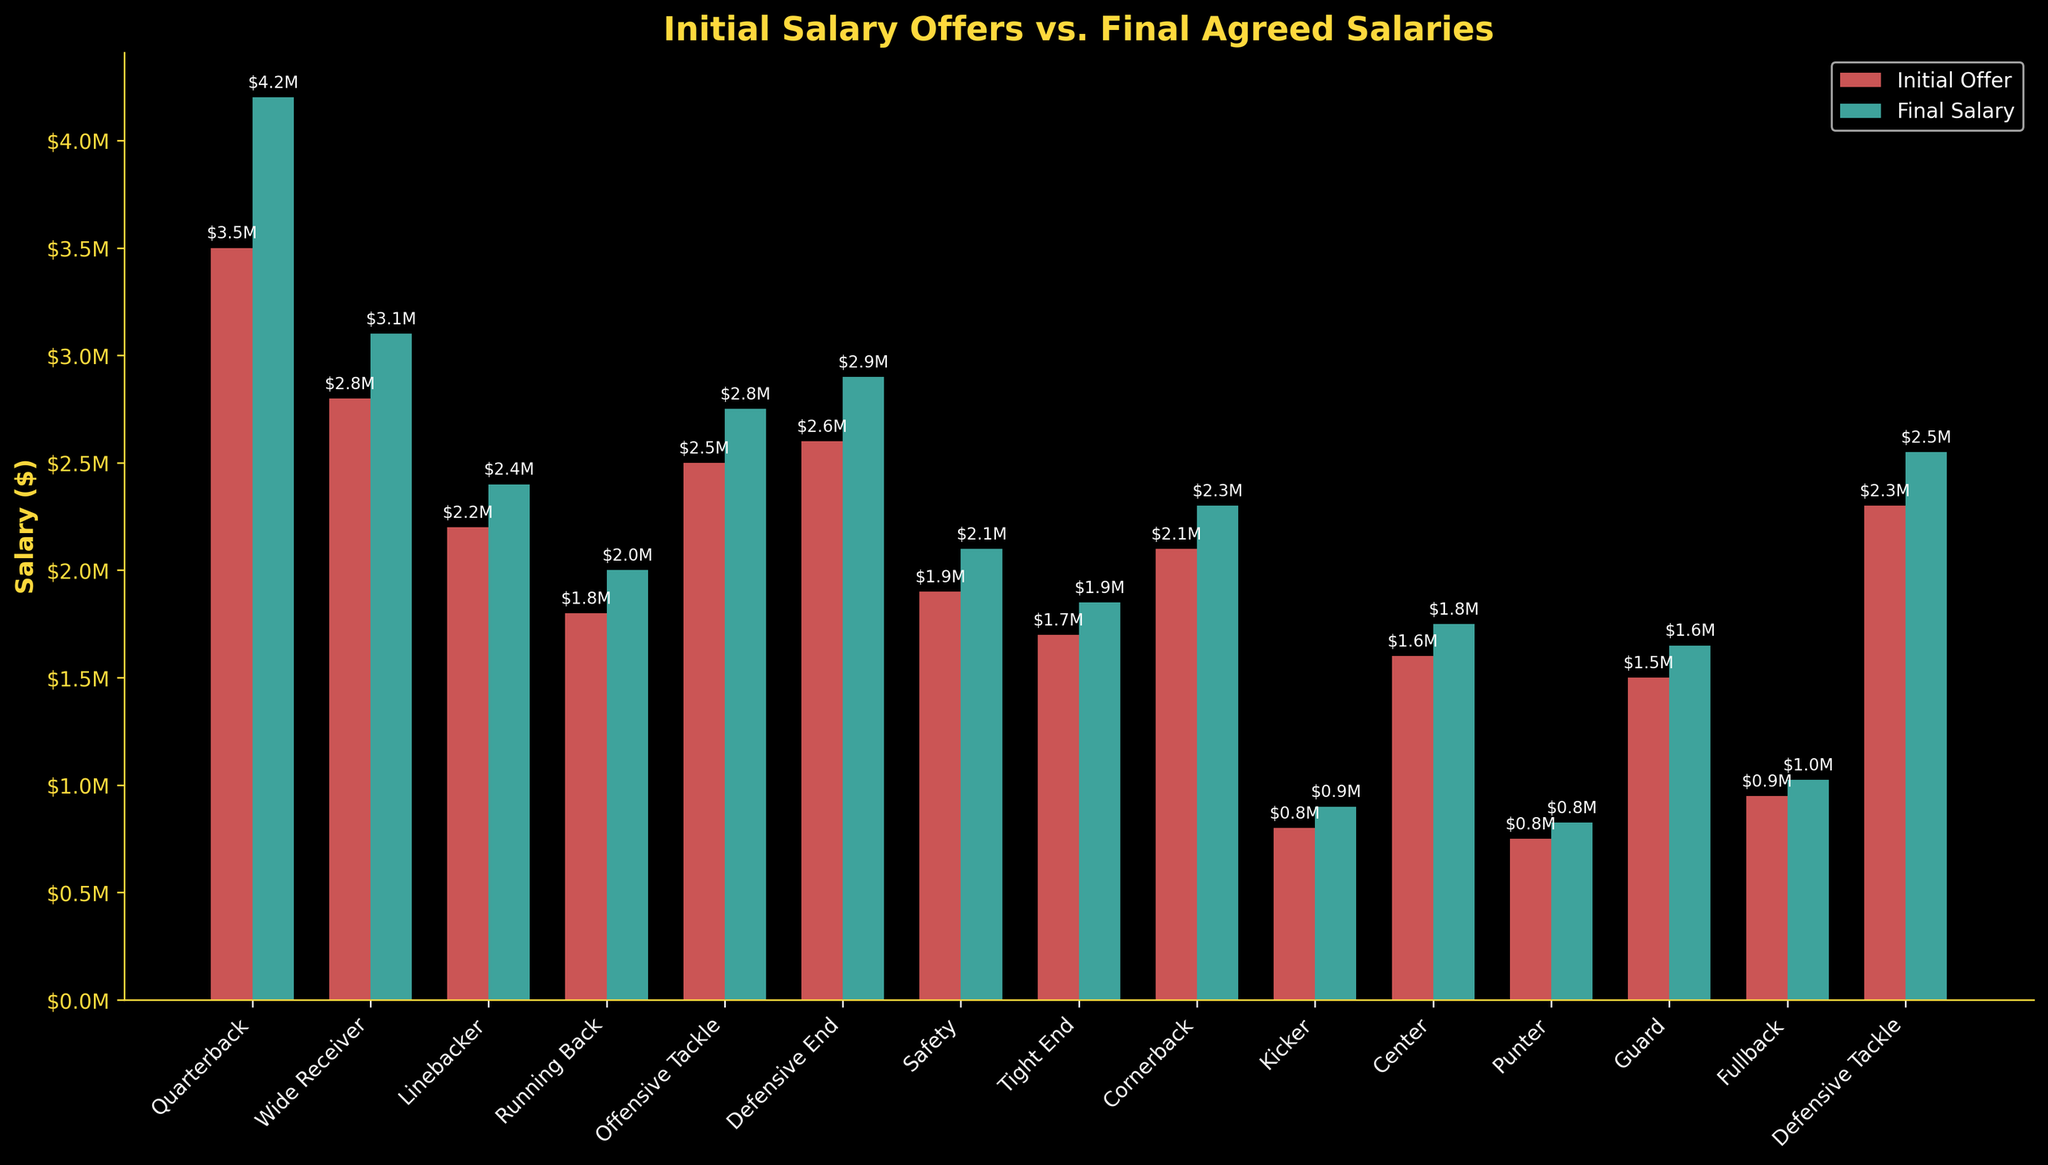what is the difference between the initial offer and the final salary for the Quarterback? To find the difference between the initial offer and final salary for the Quarterback, subtract the initial offer from the final salary: $4,200,000 - $3,500,000 = $700,000
Answer: $700,000 Which position had the smallest initial offer? By comparing the heights of the initial offer bars visually, the position with the smallest initial offer is the Punter at $750,000
Answer: Punter Which position had the largest increase from initial offer to final salary? To determine which position had the largest increase, find the differences for each position and compare them. The Quarterback had the largest increase: $4,200,000 - $3,500,000 = $700,000
Answer: Quarterback How much more is the final salary for a Running Back compared to its initial offer? The final salary for the Running Back is $2,000,000, and the initial offer is $1,800,000. The difference is $2,000,000 - $1,800,000 = $200,000
Answer: $200,000 Which positions have final salaries that are less than $2,000,000? By looking at the heights of the final salary bars, the positions with final salaries less than $2,000,000 are Tight End, Kicker, Center, and Guard
Answer: Tight End, Kicker, Center, Guard What is the combined final salary of the Defensive End and Safety? Add the final salaries of the Defensive End and Safety: $2,900,000 + $2,100,000 = $5,000,000
Answer: $5,000,000 Is the length of the final salary bar for the Wide Receiver longer than the initial offer bar? Visually, the final salary bar for the Wide Receiver is slightly longer than the initial offer bar, indicating that the final salary is higher
Answer: Yes How much higher is the final salary of a Linebacker compared to a Kicker? The final salary of the Linebacker is $2,400,000, and the final salary of the Kicker is $900,000. The difference is $2,400,000 - $900,000 = $1,500,000
Answer: $1,500,000 